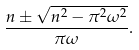<formula> <loc_0><loc_0><loc_500><loc_500>\frac { n \pm \sqrt { n ^ { 2 } - \pi ^ { 2 } \omega ^ { 2 } } } { \pi \omega } .</formula> 